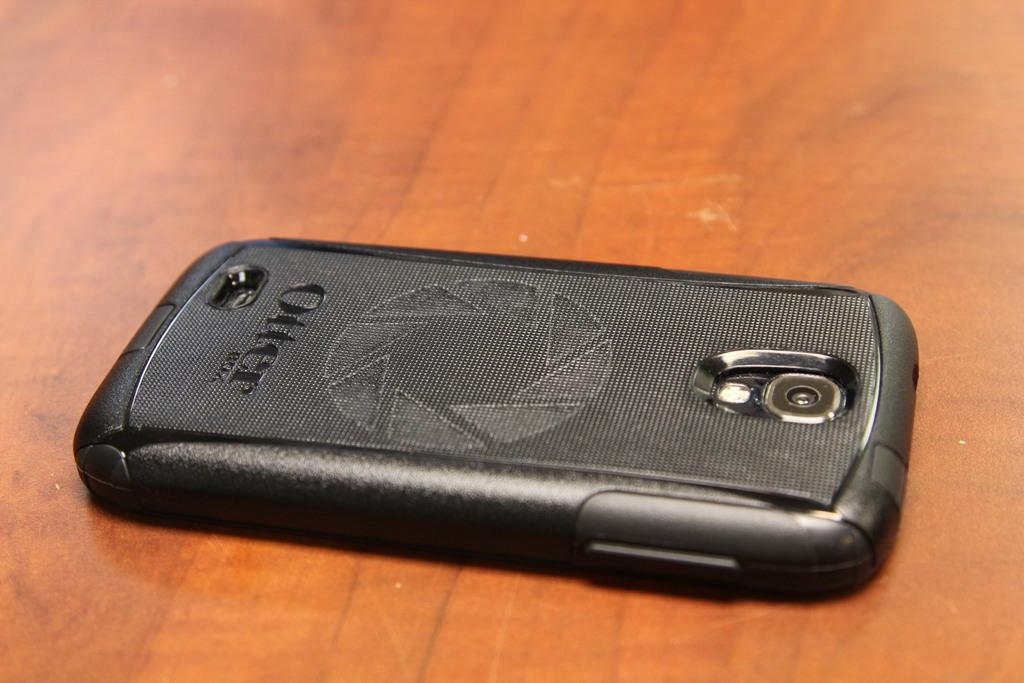<image>
Present a compact description of the photo's key features. A cell phone is protected by an Otter case. 